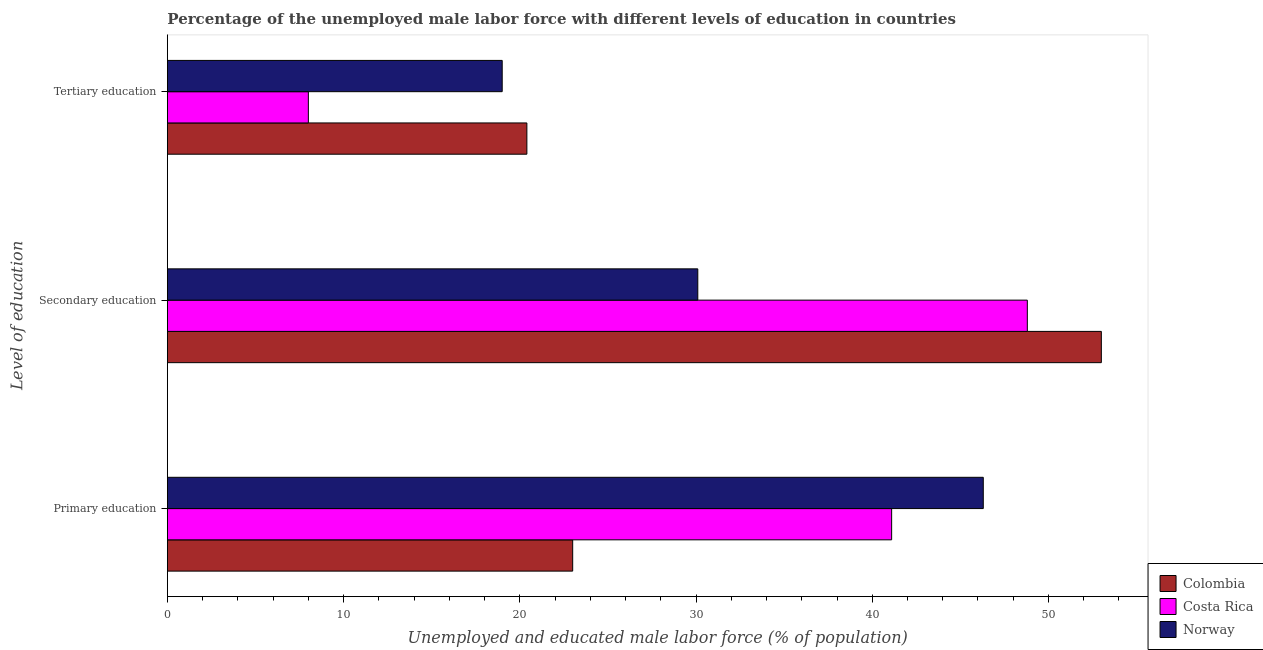How many groups of bars are there?
Provide a succinct answer. 3. Are the number of bars per tick equal to the number of legend labels?
Provide a succinct answer. Yes. Are the number of bars on each tick of the Y-axis equal?
Keep it short and to the point. Yes. How many bars are there on the 3rd tick from the bottom?
Keep it short and to the point. 3. What is the label of the 3rd group of bars from the top?
Keep it short and to the point. Primary education. What is the percentage of male labor force who received secondary education in Colombia?
Provide a succinct answer. 53. Across all countries, what is the maximum percentage of male labor force who received tertiary education?
Ensure brevity in your answer.  20.4. Across all countries, what is the minimum percentage of male labor force who received tertiary education?
Make the answer very short. 8. In which country was the percentage of male labor force who received tertiary education maximum?
Keep it short and to the point. Colombia. What is the total percentage of male labor force who received primary education in the graph?
Offer a very short reply. 110.4. What is the difference between the percentage of male labor force who received primary education in Norway and that in Colombia?
Provide a short and direct response. 23.3. What is the difference between the percentage of male labor force who received secondary education in Colombia and the percentage of male labor force who received primary education in Norway?
Keep it short and to the point. 6.7. What is the average percentage of male labor force who received tertiary education per country?
Your response must be concise. 15.8. What is the difference between the percentage of male labor force who received secondary education and percentage of male labor force who received tertiary education in Norway?
Your answer should be very brief. 11.1. What is the ratio of the percentage of male labor force who received primary education in Costa Rica to that in Norway?
Your answer should be compact. 0.89. Is the percentage of male labor force who received tertiary education in Norway less than that in Costa Rica?
Your response must be concise. No. What is the difference between the highest and the second highest percentage of male labor force who received tertiary education?
Make the answer very short. 1.4. What is the difference between the highest and the lowest percentage of male labor force who received tertiary education?
Make the answer very short. 12.4. In how many countries, is the percentage of male labor force who received secondary education greater than the average percentage of male labor force who received secondary education taken over all countries?
Your answer should be compact. 2. Are the values on the major ticks of X-axis written in scientific E-notation?
Your answer should be compact. No. Does the graph contain any zero values?
Give a very brief answer. No. How are the legend labels stacked?
Keep it short and to the point. Vertical. What is the title of the graph?
Provide a succinct answer. Percentage of the unemployed male labor force with different levels of education in countries. Does "Iran" appear as one of the legend labels in the graph?
Offer a terse response. No. What is the label or title of the X-axis?
Ensure brevity in your answer.  Unemployed and educated male labor force (% of population). What is the label or title of the Y-axis?
Keep it short and to the point. Level of education. What is the Unemployed and educated male labor force (% of population) of Colombia in Primary education?
Offer a very short reply. 23. What is the Unemployed and educated male labor force (% of population) of Costa Rica in Primary education?
Provide a short and direct response. 41.1. What is the Unemployed and educated male labor force (% of population) in Norway in Primary education?
Offer a terse response. 46.3. What is the Unemployed and educated male labor force (% of population) of Costa Rica in Secondary education?
Provide a succinct answer. 48.8. What is the Unemployed and educated male labor force (% of population) of Norway in Secondary education?
Keep it short and to the point. 30.1. What is the Unemployed and educated male labor force (% of population) of Colombia in Tertiary education?
Your answer should be compact. 20.4. What is the Unemployed and educated male labor force (% of population) of Norway in Tertiary education?
Your answer should be compact. 19. Across all Level of education, what is the maximum Unemployed and educated male labor force (% of population) in Costa Rica?
Provide a succinct answer. 48.8. Across all Level of education, what is the maximum Unemployed and educated male labor force (% of population) of Norway?
Your response must be concise. 46.3. Across all Level of education, what is the minimum Unemployed and educated male labor force (% of population) of Colombia?
Your response must be concise. 20.4. Across all Level of education, what is the minimum Unemployed and educated male labor force (% of population) in Costa Rica?
Provide a short and direct response. 8. Across all Level of education, what is the minimum Unemployed and educated male labor force (% of population) in Norway?
Ensure brevity in your answer.  19. What is the total Unemployed and educated male labor force (% of population) of Colombia in the graph?
Give a very brief answer. 96.4. What is the total Unemployed and educated male labor force (% of population) in Costa Rica in the graph?
Ensure brevity in your answer.  97.9. What is the total Unemployed and educated male labor force (% of population) in Norway in the graph?
Provide a succinct answer. 95.4. What is the difference between the Unemployed and educated male labor force (% of population) in Colombia in Primary education and that in Secondary education?
Your response must be concise. -30. What is the difference between the Unemployed and educated male labor force (% of population) of Costa Rica in Primary education and that in Secondary education?
Ensure brevity in your answer.  -7.7. What is the difference between the Unemployed and educated male labor force (% of population) in Norway in Primary education and that in Secondary education?
Your answer should be very brief. 16.2. What is the difference between the Unemployed and educated male labor force (% of population) in Costa Rica in Primary education and that in Tertiary education?
Give a very brief answer. 33.1. What is the difference between the Unemployed and educated male labor force (% of population) of Norway in Primary education and that in Tertiary education?
Your answer should be very brief. 27.3. What is the difference between the Unemployed and educated male labor force (% of population) of Colombia in Secondary education and that in Tertiary education?
Ensure brevity in your answer.  32.6. What is the difference between the Unemployed and educated male labor force (% of population) in Costa Rica in Secondary education and that in Tertiary education?
Keep it short and to the point. 40.8. What is the difference between the Unemployed and educated male labor force (% of population) in Colombia in Primary education and the Unemployed and educated male labor force (% of population) in Costa Rica in Secondary education?
Give a very brief answer. -25.8. What is the difference between the Unemployed and educated male labor force (% of population) in Colombia in Primary education and the Unemployed and educated male labor force (% of population) in Norway in Secondary education?
Provide a short and direct response. -7.1. What is the difference between the Unemployed and educated male labor force (% of population) in Costa Rica in Primary education and the Unemployed and educated male labor force (% of population) in Norway in Tertiary education?
Offer a terse response. 22.1. What is the difference between the Unemployed and educated male labor force (% of population) of Colombia in Secondary education and the Unemployed and educated male labor force (% of population) of Costa Rica in Tertiary education?
Provide a short and direct response. 45. What is the difference between the Unemployed and educated male labor force (% of population) of Costa Rica in Secondary education and the Unemployed and educated male labor force (% of population) of Norway in Tertiary education?
Your answer should be very brief. 29.8. What is the average Unemployed and educated male labor force (% of population) in Colombia per Level of education?
Ensure brevity in your answer.  32.13. What is the average Unemployed and educated male labor force (% of population) of Costa Rica per Level of education?
Your answer should be very brief. 32.63. What is the average Unemployed and educated male labor force (% of population) of Norway per Level of education?
Offer a very short reply. 31.8. What is the difference between the Unemployed and educated male labor force (% of population) of Colombia and Unemployed and educated male labor force (% of population) of Costa Rica in Primary education?
Keep it short and to the point. -18.1. What is the difference between the Unemployed and educated male labor force (% of population) in Colombia and Unemployed and educated male labor force (% of population) in Norway in Primary education?
Give a very brief answer. -23.3. What is the difference between the Unemployed and educated male labor force (% of population) in Colombia and Unemployed and educated male labor force (% of population) in Norway in Secondary education?
Your response must be concise. 22.9. What is the difference between the Unemployed and educated male labor force (% of population) in Colombia and Unemployed and educated male labor force (% of population) in Norway in Tertiary education?
Provide a short and direct response. 1.4. What is the ratio of the Unemployed and educated male labor force (% of population) of Colombia in Primary education to that in Secondary education?
Make the answer very short. 0.43. What is the ratio of the Unemployed and educated male labor force (% of population) of Costa Rica in Primary education to that in Secondary education?
Offer a very short reply. 0.84. What is the ratio of the Unemployed and educated male labor force (% of population) of Norway in Primary education to that in Secondary education?
Your answer should be compact. 1.54. What is the ratio of the Unemployed and educated male labor force (% of population) in Colombia in Primary education to that in Tertiary education?
Your response must be concise. 1.13. What is the ratio of the Unemployed and educated male labor force (% of population) in Costa Rica in Primary education to that in Tertiary education?
Give a very brief answer. 5.14. What is the ratio of the Unemployed and educated male labor force (% of population) of Norway in Primary education to that in Tertiary education?
Offer a very short reply. 2.44. What is the ratio of the Unemployed and educated male labor force (% of population) in Colombia in Secondary education to that in Tertiary education?
Provide a succinct answer. 2.6. What is the ratio of the Unemployed and educated male labor force (% of population) of Norway in Secondary education to that in Tertiary education?
Offer a very short reply. 1.58. What is the difference between the highest and the second highest Unemployed and educated male labor force (% of population) in Colombia?
Provide a short and direct response. 30. What is the difference between the highest and the second highest Unemployed and educated male labor force (% of population) of Costa Rica?
Your response must be concise. 7.7. What is the difference between the highest and the lowest Unemployed and educated male labor force (% of population) in Colombia?
Keep it short and to the point. 32.6. What is the difference between the highest and the lowest Unemployed and educated male labor force (% of population) of Costa Rica?
Make the answer very short. 40.8. What is the difference between the highest and the lowest Unemployed and educated male labor force (% of population) in Norway?
Offer a terse response. 27.3. 